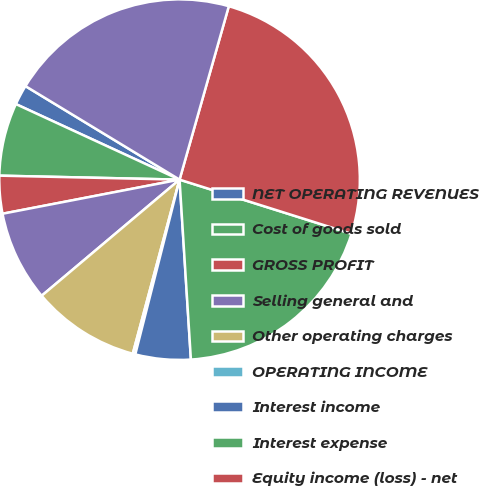<chart> <loc_0><loc_0><loc_500><loc_500><pie_chart><fcel>NET OPERATING REVENUES<fcel>Cost of goods sold<fcel>GROSS PROFIT<fcel>Selling general and<fcel>Other operating charges<fcel>OPERATING INCOME<fcel>Interest income<fcel>Interest expense<fcel>Equity income (loss) - net<fcel>INCOME FROM CONTINUING<nl><fcel>1.8%<fcel>6.53%<fcel>3.38%<fcel>8.11%<fcel>9.68%<fcel>0.23%<fcel>4.95%<fcel>19.14%<fcel>25.45%<fcel>20.72%<nl></chart> 